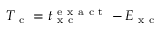Convert formula to latex. <formula><loc_0><loc_0><loc_500><loc_500>T _ { c } = t _ { x c } ^ { e x a c t } - E _ { x c }</formula> 